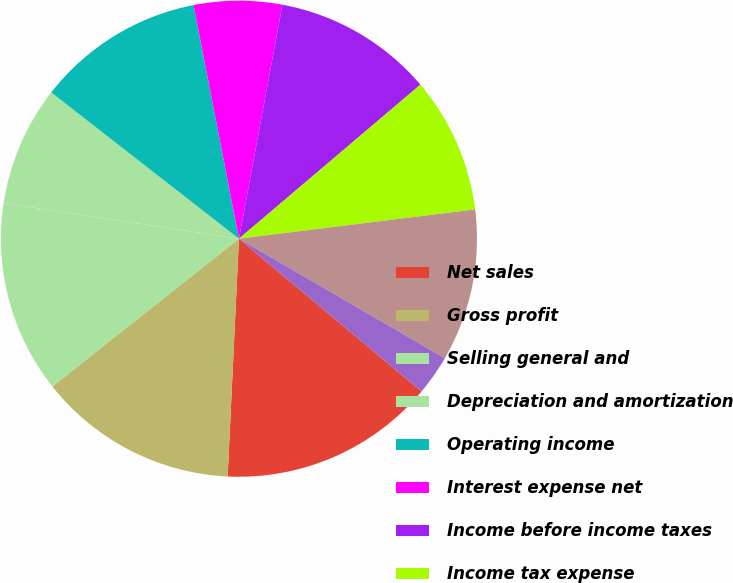Convert chart to OTSL. <chart><loc_0><loc_0><loc_500><loc_500><pie_chart><fcel>Net sales<fcel>Gross profit<fcel>Selling general and<fcel>Depreciation and amortization<fcel>Operating income<fcel>Interest expense net<fcel>Income before income taxes<fcel>Income tax expense<fcel>Net income<fcel>Net income per share - basic<nl><fcel>14.67%<fcel>13.59%<fcel>13.04%<fcel>8.15%<fcel>11.41%<fcel>5.98%<fcel>10.87%<fcel>9.24%<fcel>10.33%<fcel>2.72%<nl></chart> 